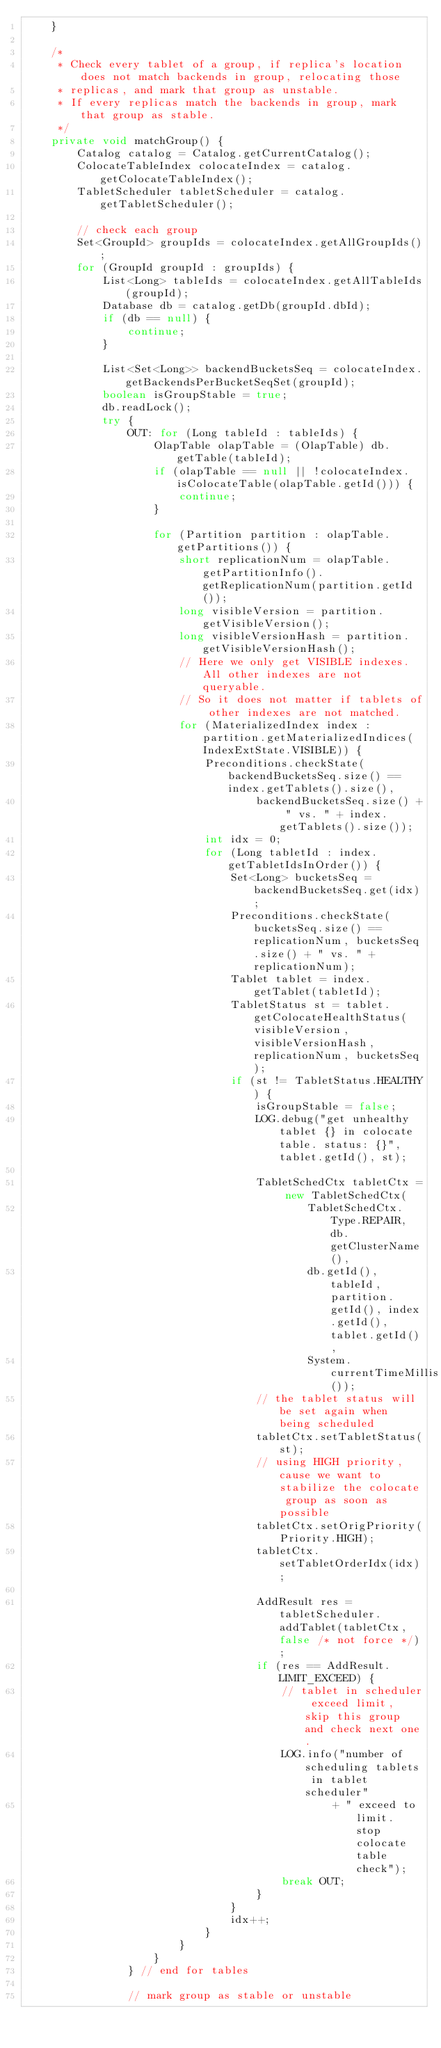Convert code to text. <code><loc_0><loc_0><loc_500><loc_500><_Java_>    }

    /*
     * Check every tablet of a group, if replica's location does not match backends in group, relocating those
     * replicas, and mark that group as unstable.
     * If every replicas match the backends in group, mark that group as stable.
     */
    private void matchGroup() {
        Catalog catalog = Catalog.getCurrentCatalog();
        ColocateTableIndex colocateIndex = catalog.getColocateTableIndex();
        TabletScheduler tabletScheduler = catalog.getTabletScheduler();

        // check each group
        Set<GroupId> groupIds = colocateIndex.getAllGroupIds();
        for (GroupId groupId : groupIds) {
            List<Long> tableIds = colocateIndex.getAllTableIds(groupId);
            Database db = catalog.getDb(groupId.dbId);
            if (db == null) {
                continue;
            }

            List<Set<Long>> backendBucketsSeq = colocateIndex.getBackendsPerBucketSeqSet(groupId);
            boolean isGroupStable = true;
            db.readLock();
            try {
                OUT: for (Long tableId : tableIds) {
                    OlapTable olapTable = (OlapTable) db.getTable(tableId);
                    if (olapTable == null || !colocateIndex.isColocateTable(olapTable.getId())) {
                        continue;
                    }

                    for (Partition partition : olapTable.getPartitions()) {
                        short replicationNum = olapTable.getPartitionInfo().getReplicationNum(partition.getId());
                        long visibleVersion = partition.getVisibleVersion();
                        long visibleVersionHash = partition.getVisibleVersionHash();
                        // Here we only get VISIBLE indexes. All other indexes are not queryable.
                        // So it does not matter if tablets of other indexes are not matched.
                        for (MaterializedIndex index : partition.getMaterializedIndices(IndexExtState.VISIBLE)) {
                            Preconditions.checkState(backendBucketsSeq.size() == index.getTablets().size(),
                                    backendBucketsSeq.size() + " vs. " + index.getTablets().size());
                            int idx = 0;
                            for (Long tabletId : index.getTabletIdsInOrder()) {
                                Set<Long> bucketsSeq = backendBucketsSeq.get(idx);
                                Preconditions.checkState(bucketsSeq.size() == replicationNum, bucketsSeq.size() + " vs. " + replicationNum);
                                Tablet tablet = index.getTablet(tabletId);
                                TabletStatus st = tablet.getColocateHealthStatus(visibleVersion, visibleVersionHash, replicationNum, bucketsSeq);
                                if (st != TabletStatus.HEALTHY) {
                                    isGroupStable = false;
                                    LOG.debug("get unhealthy tablet {} in colocate table. status: {}", tablet.getId(), st);

                                    TabletSchedCtx tabletCtx = new TabletSchedCtx(
                                            TabletSchedCtx.Type.REPAIR, db.getClusterName(),
                                            db.getId(), tableId, partition.getId(), index.getId(), tablet.getId(),
                                            System.currentTimeMillis());
                                    // the tablet status will be set again when being scheduled
                                    tabletCtx.setTabletStatus(st);
                                    // using HIGH priority, cause we want to stabilize the colocate group as soon as possible
                                    tabletCtx.setOrigPriority(Priority.HIGH);
                                    tabletCtx.setTabletOrderIdx(idx);

                                    AddResult res = tabletScheduler.addTablet(tabletCtx, false /* not force */);
                                    if (res == AddResult.LIMIT_EXCEED) {
                                        // tablet in scheduler exceed limit, skip this group and check next one.
                                        LOG.info("number of scheduling tablets in tablet scheduler"
                                                + " exceed to limit. stop colocate table check");
                                        break OUT;
                                    }
                                }
                                idx++;
                            }
                        }
                    }
                } // end for tables

                // mark group as stable or unstable</code> 